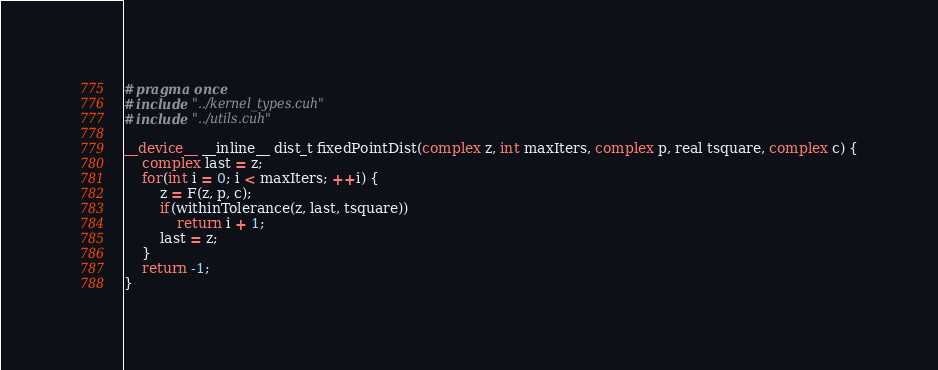Convert code to text. <code><loc_0><loc_0><loc_500><loc_500><_Cuda_>#pragma once
#include "../kernel_types.cuh"
#include "../utils.cuh"

__device__ __inline__ dist_t fixedPointDist(complex z, int maxIters, complex p, real tsquare, complex c) {
    complex last = z;
    for(int i = 0; i < maxIters; ++i) {
        z = F(z, p, c);
        if(withinTolerance(z, last, tsquare))
            return i + 1;
        last = z;
    }
    return -1;
}</code> 